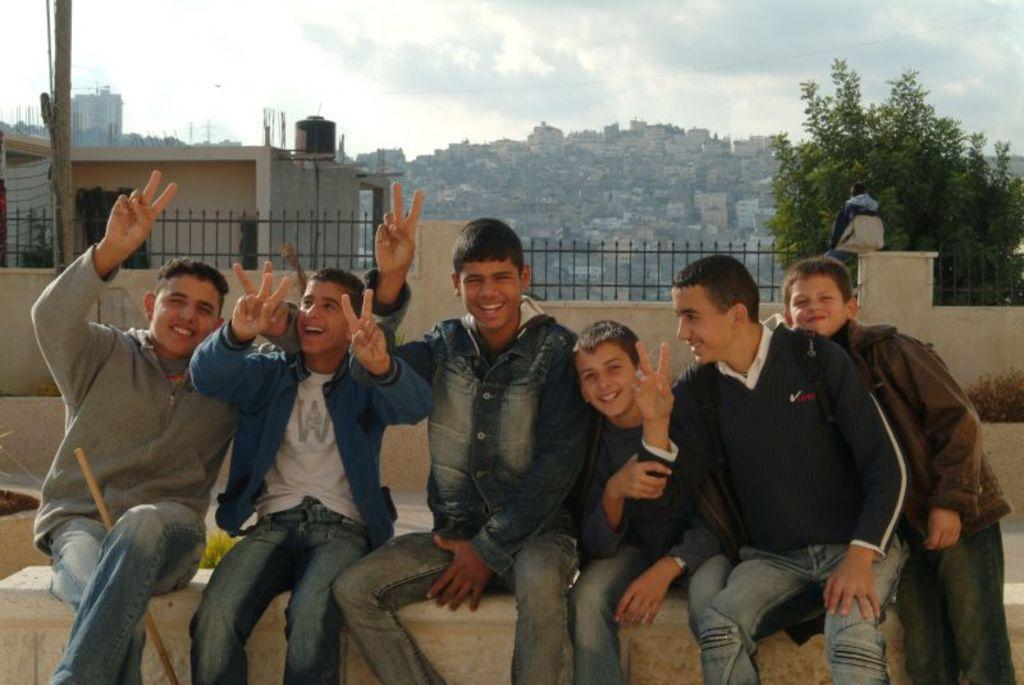What are the boys in the image doing? The boys are sitting in the center of the image and laughing. What can be seen in the background of the image? There are houses in the background of the image. What type of vegetation is present in the image? There is a tree in the image. What is visible at the top of the image? The sky is visible at the top of the image. What type of wristwatch is the boy wearing in the image? There is no wristwatch visible on the boys in the image. What record is the boy holding in the image? There is no record present in the image. 